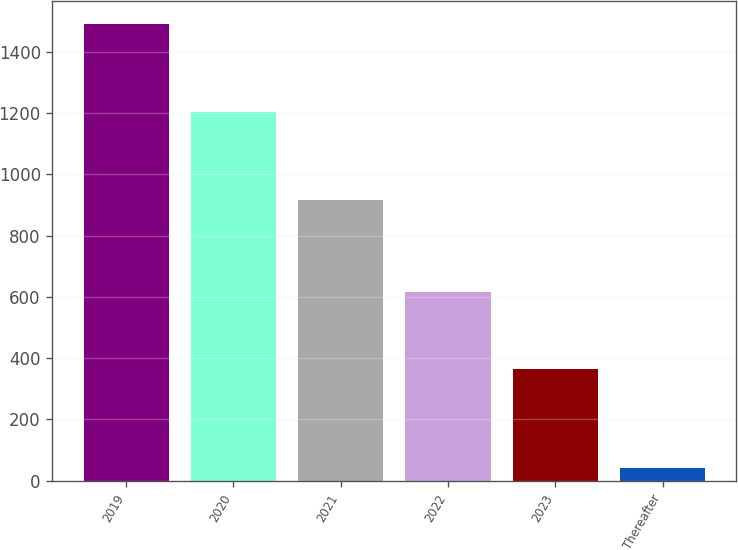<chart> <loc_0><loc_0><loc_500><loc_500><bar_chart><fcel>2019<fcel>2020<fcel>2021<fcel>2022<fcel>2023<fcel>Thereafter<nl><fcel>1491.1<fcel>1203.1<fcel>916.1<fcel>616.6<fcel>363.4<fcel>40.2<nl></chart> 